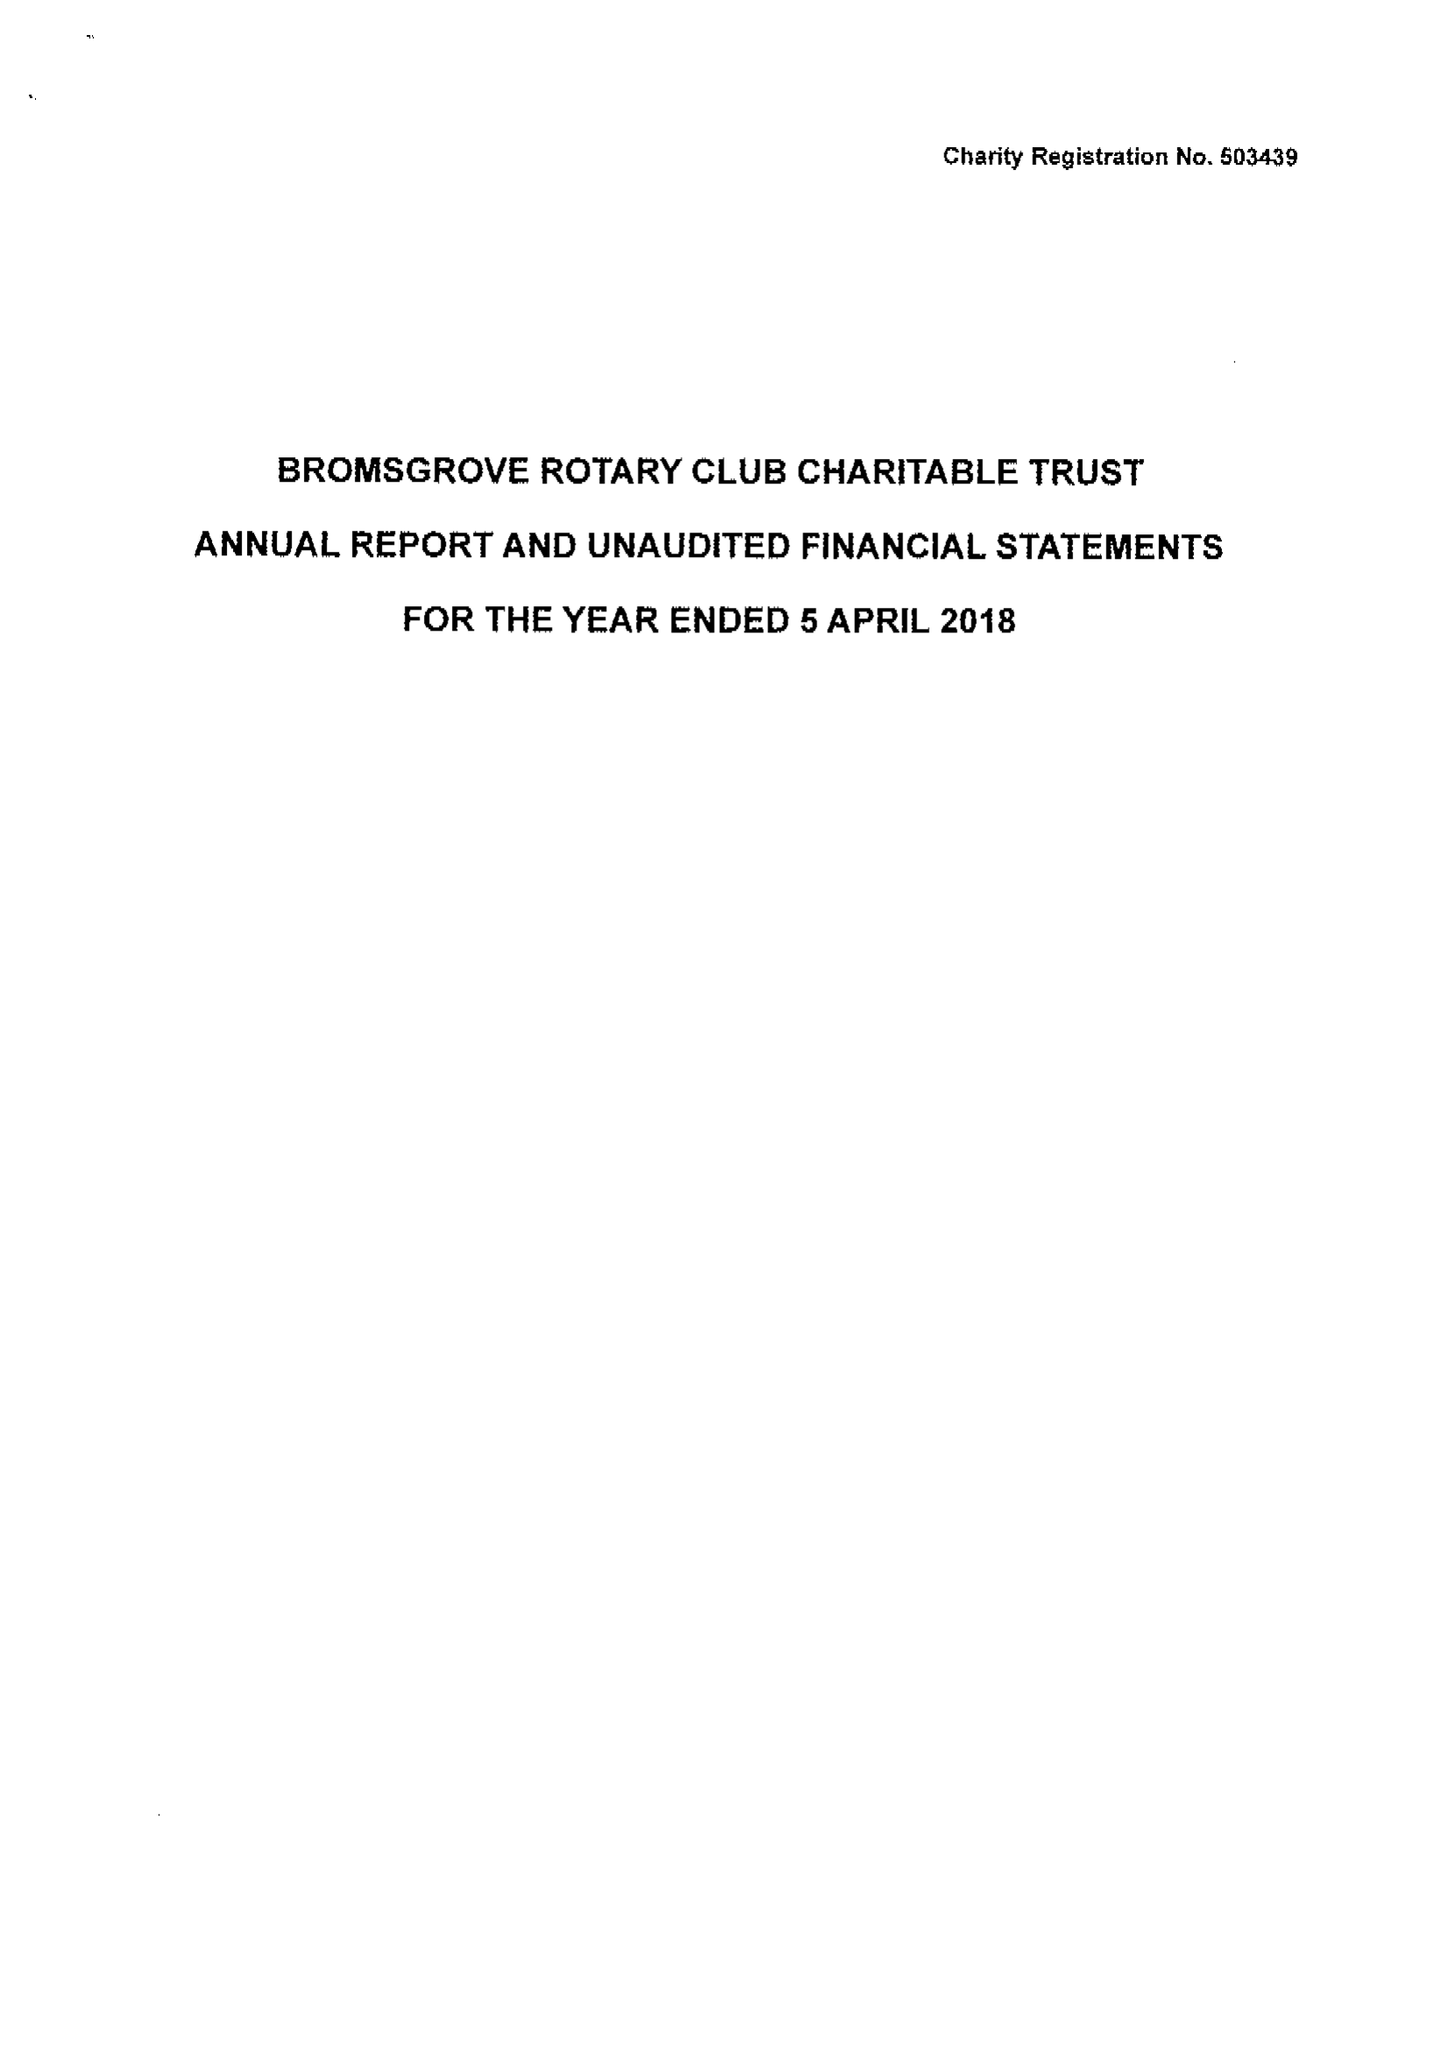What is the value for the charity_number?
Answer the question using a single word or phrase. 503439 